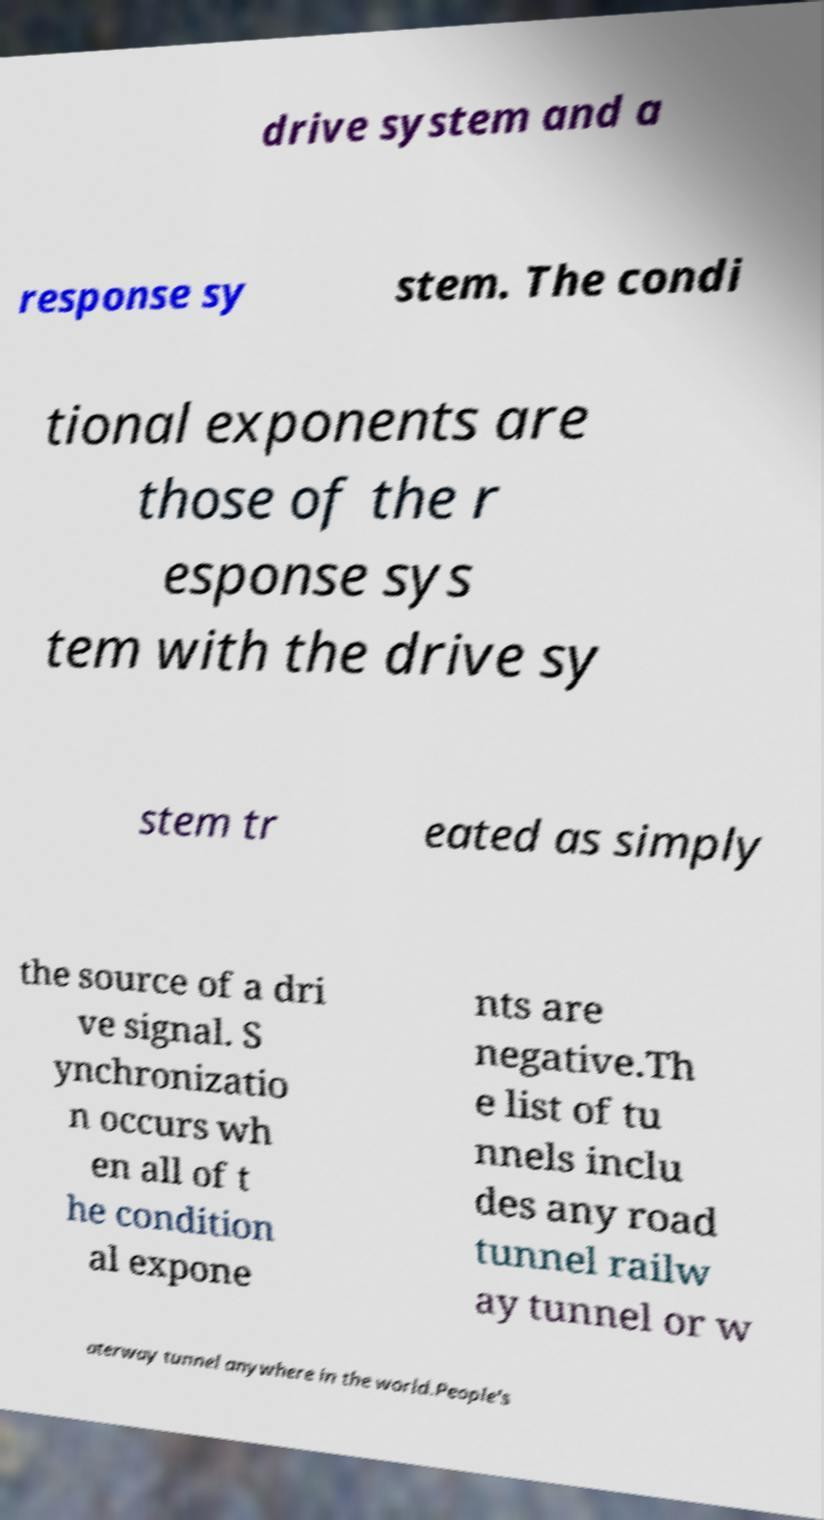Can you read and provide the text displayed in the image?This photo seems to have some interesting text. Can you extract and type it out for me? drive system and a response sy stem. The condi tional exponents are those of the r esponse sys tem with the drive sy stem tr eated as simply the source of a dri ve signal. S ynchronizatio n occurs wh en all of t he condition al expone nts are negative.Th e list of tu nnels inclu des any road tunnel railw ay tunnel or w aterway tunnel anywhere in the world.People's 